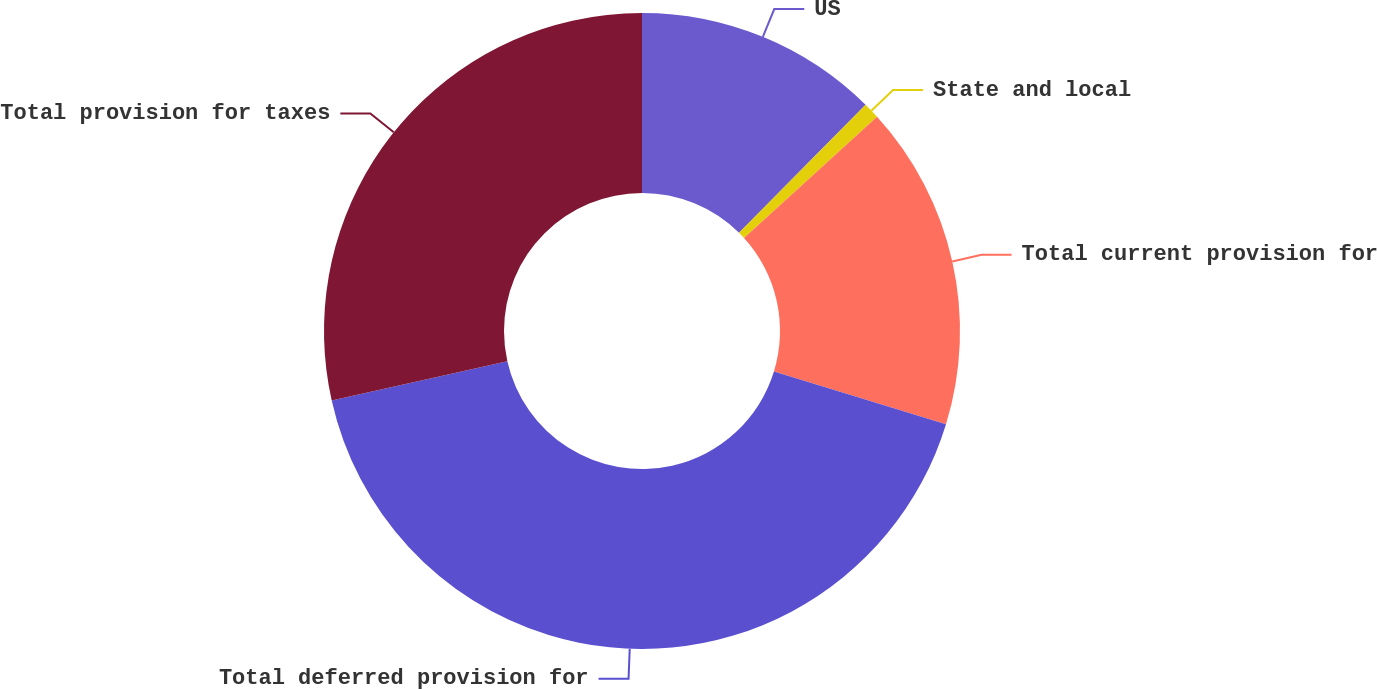<chart> <loc_0><loc_0><loc_500><loc_500><pie_chart><fcel>US<fcel>State and local<fcel>Total current provision for<fcel>Total deferred provision for<fcel>Total provision for taxes<nl><fcel>12.41%<fcel>0.83%<fcel>16.5%<fcel>41.75%<fcel>28.51%<nl></chart> 